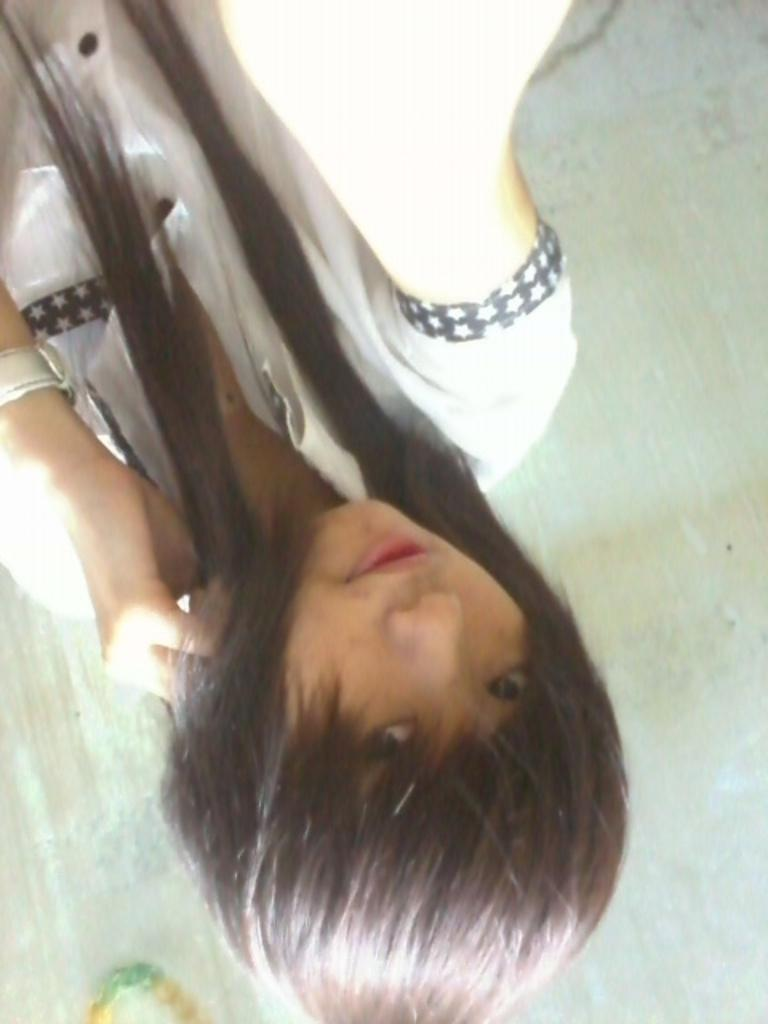Who is the main subject in the image? There is a girl in the image. What is the girl doing in the image? The girl is in an inverted position. What is the girl wearing in the image? The girl is wearing a white dress. What can be said about the girl's hair in the image? The girl has long hair. What country is the girl visiting during her holiday in the image? There is no information about the girl visiting a country or going on a holiday in the image. 